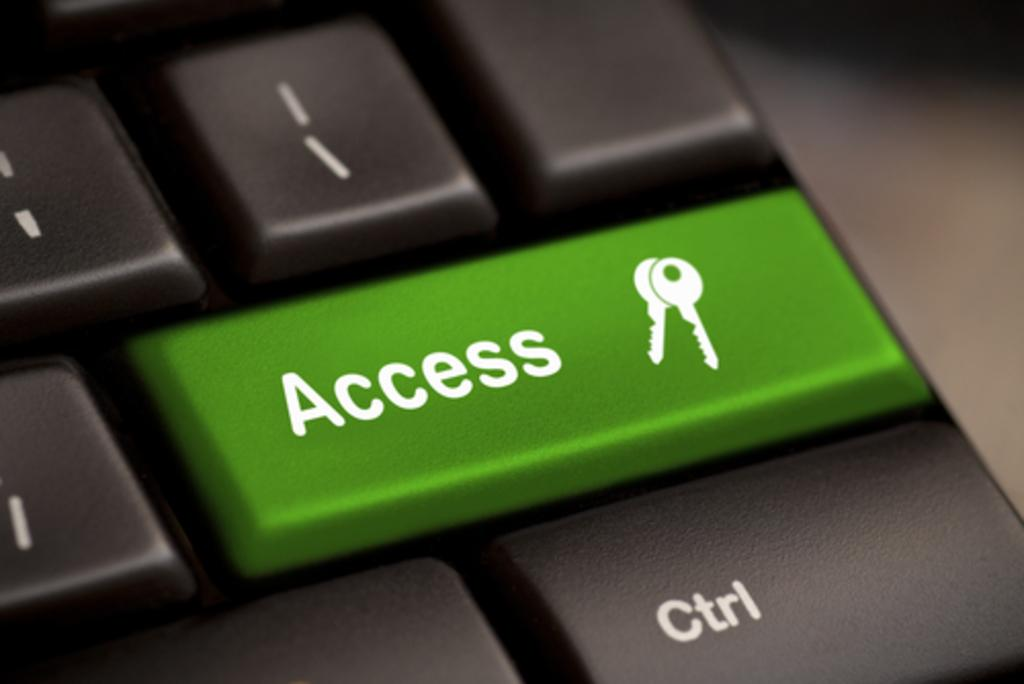<image>
Give a short and clear explanation of the subsequent image. keyboard keys with one of them being green and labeled 'access' 